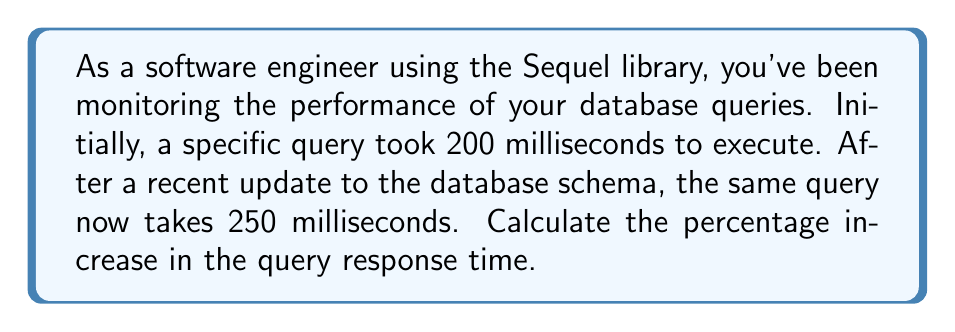Solve this math problem. To calculate the percentage increase, we need to follow these steps:

1. Calculate the difference between the new and original values:
   $\text{Difference} = \text{New Value} - \text{Original Value}$
   $\text{Difference} = 250 \text{ ms} - 200 \text{ ms} = 50 \text{ ms}$

2. Divide the difference by the original value:
   $\text{Ratio} = \frac{\text{Difference}}{\text{Original Value}} = \frac{50 \text{ ms}}{200 \text{ ms}} = 0.25$

3. Convert the ratio to a percentage by multiplying by 100:
   $\text{Percentage Increase} = \text{Ratio} \times 100\%$
   $\text{Percentage Increase} = 0.25 \times 100\% = 25\%$

Alternatively, we can use the percentage increase formula:

$$\text{Percentage Increase} = \frac{\text{New Value} - \text{Original Value}}{\text{Original Value}} \times 100\%$$

$$\text{Percentage Increase} = \frac{250 \text{ ms} - 200 \text{ ms}}{200 \text{ ms}} \times 100\% = \frac{50 \text{ ms}}{200 \text{ ms}} \times 100\% = 0.25 \times 100\% = 25\%$$
Answer: The percentage increase in the database query response time is 25%. 